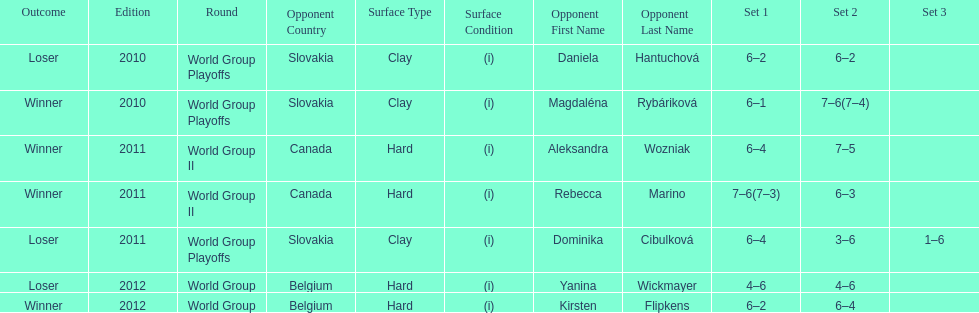What was the next game listed after the world group ii rounds? World Group Playoffs. 